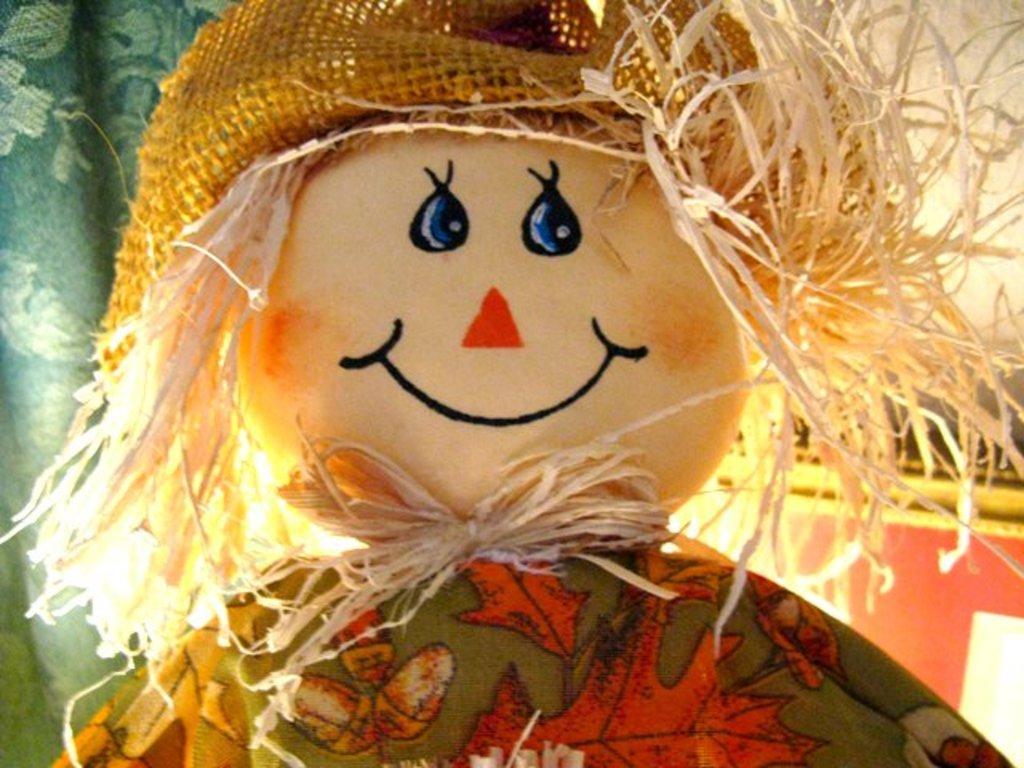Can you describe this image briefly? In this image I can see the toy. The toy has colorful dress and the net hat. In the back I can see the green color cloth and the board. 